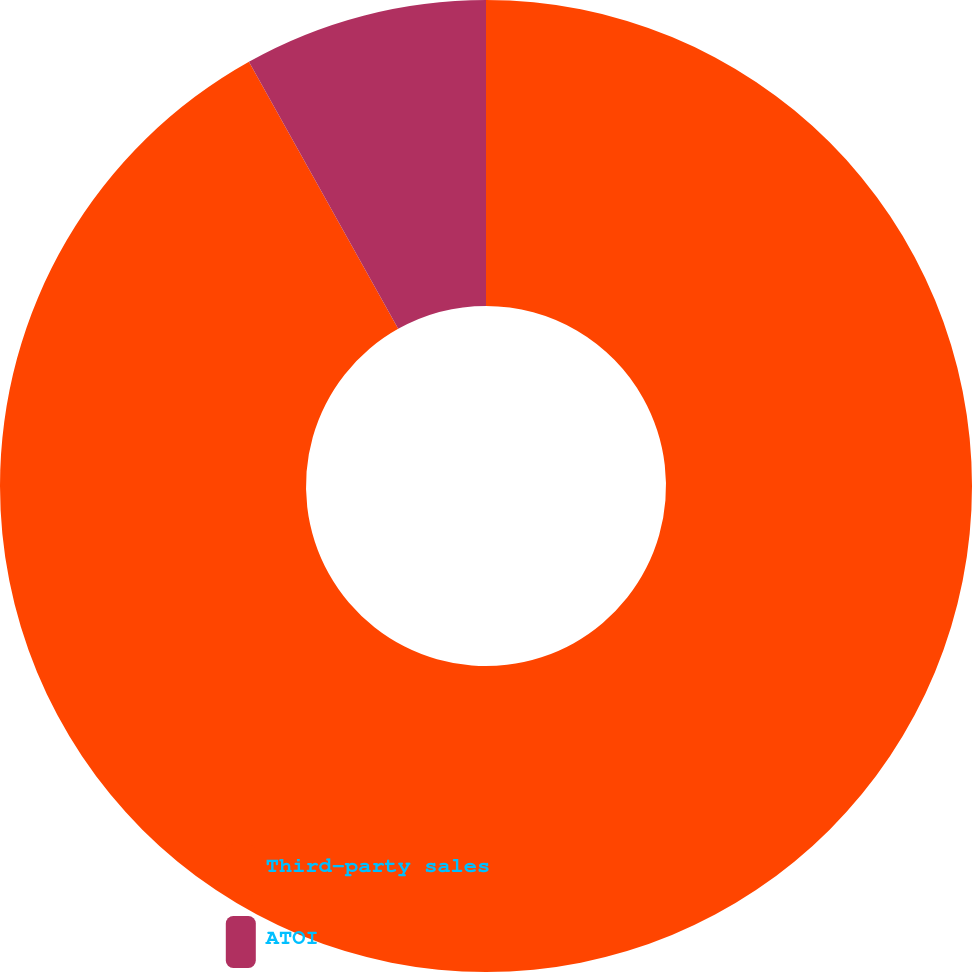<chart> <loc_0><loc_0><loc_500><loc_500><pie_chart><fcel>Third-party sales<fcel>ATOI<nl><fcel>91.89%<fcel>8.11%<nl></chart> 